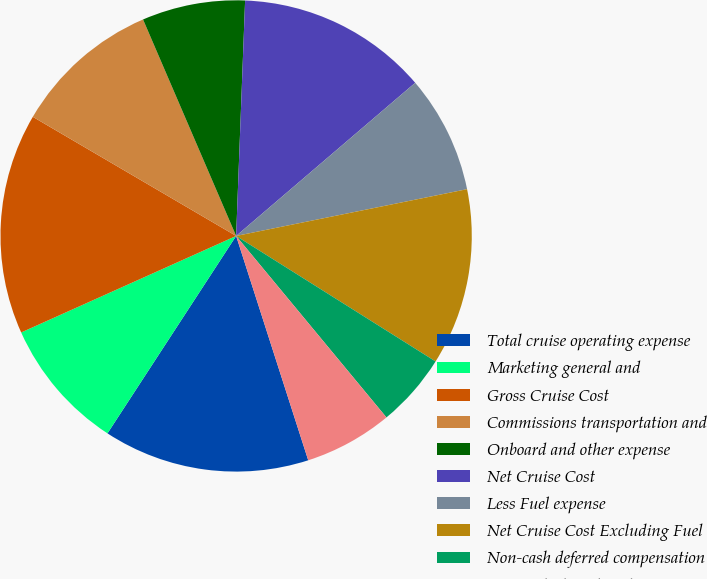Convert chart. <chart><loc_0><loc_0><loc_500><loc_500><pie_chart><fcel>Total cruise operating expense<fcel>Marketing general and<fcel>Gross Cruise Cost<fcel>Commissions transportation and<fcel>Onboard and other expense<fcel>Net Cruise Cost<fcel>Less Fuel expense<fcel>Net Cruise Cost Excluding Fuel<fcel>Non-cash deferred compensation<fcel>Non-cash share-based<nl><fcel>14.14%<fcel>9.09%<fcel>15.15%<fcel>10.1%<fcel>7.07%<fcel>13.13%<fcel>8.08%<fcel>12.12%<fcel>5.05%<fcel>6.06%<nl></chart> 